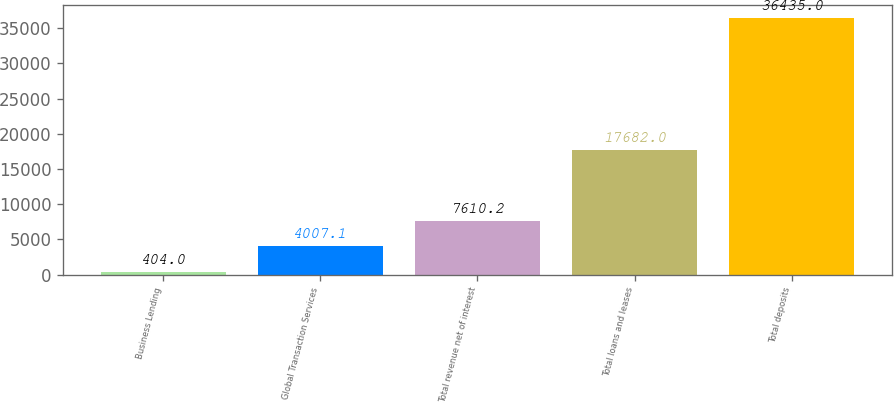Convert chart to OTSL. <chart><loc_0><loc_0><loc_500><loc_500><bar_chart><fcel>Business Lending<fcel>Global Transaction Services<fcel>Total revenue net of interest<fcel>Total loans and leases<fcel>Total deposits<nl><fcel>404<fcel>4007.1<fcel>7610.2<fcel>17682<fcel>36435<nl></chart> 